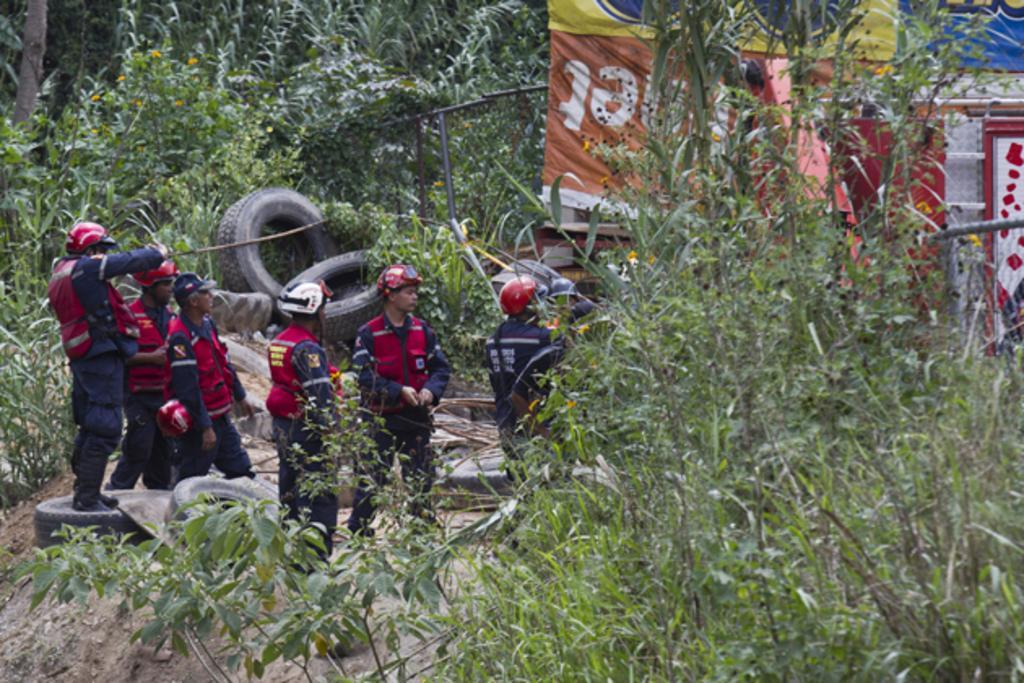In one or two sentences, can you explain what this image depicts? In the image I can see some people wearing same dress and standing on the floor on which there are some tires and around there are some trees, plants and some posters. 